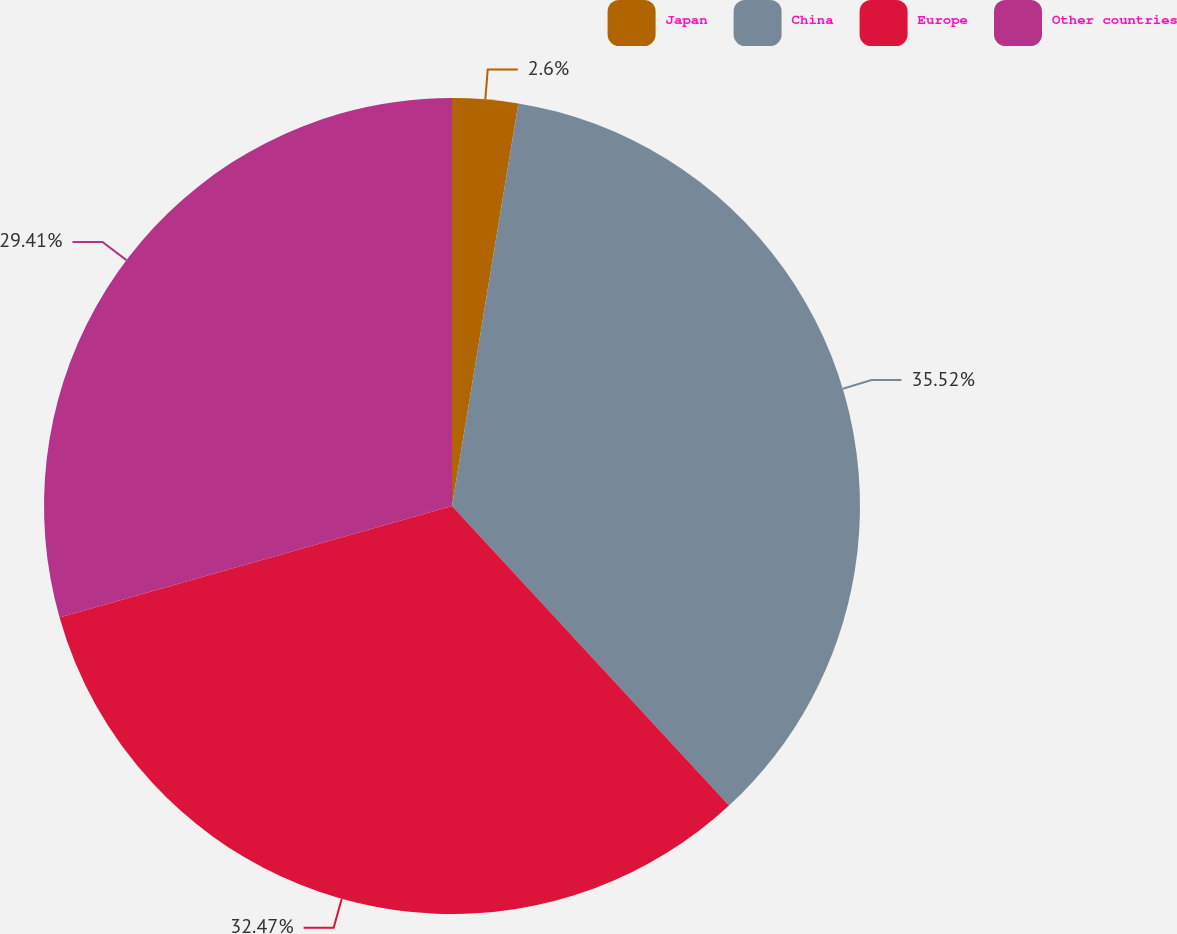<chart> <loc_0><loc_0><loc_500><loc_500><pie_chart><fcel>Japan<fcel>China<fcel>Europe<fcel>Other countries<nl><fcel>2.6%<fcel>35.52%<fcel>32.47%<fcel>29.41%<nl></chart> 